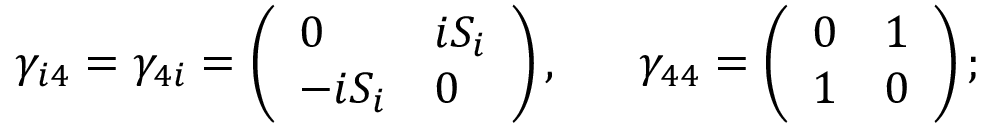<formula> <loc_0><loc_0><loc_500><loc_500>\gamma _ { i 4 } = \gamma _ { 4 i } = \left ( \begin{array} { l l } { 0 } & { { i S _ { i } } } \\ { { - i S _ { i } } } & { 0 } \end{array} \right ) , \quad \ \gamma _ { 4 4 } = \left ( \begin{array} { l l } { 0 } & { 1 } \\ { 1 } & { 0 } \end{array} \right ) ;</formula> 